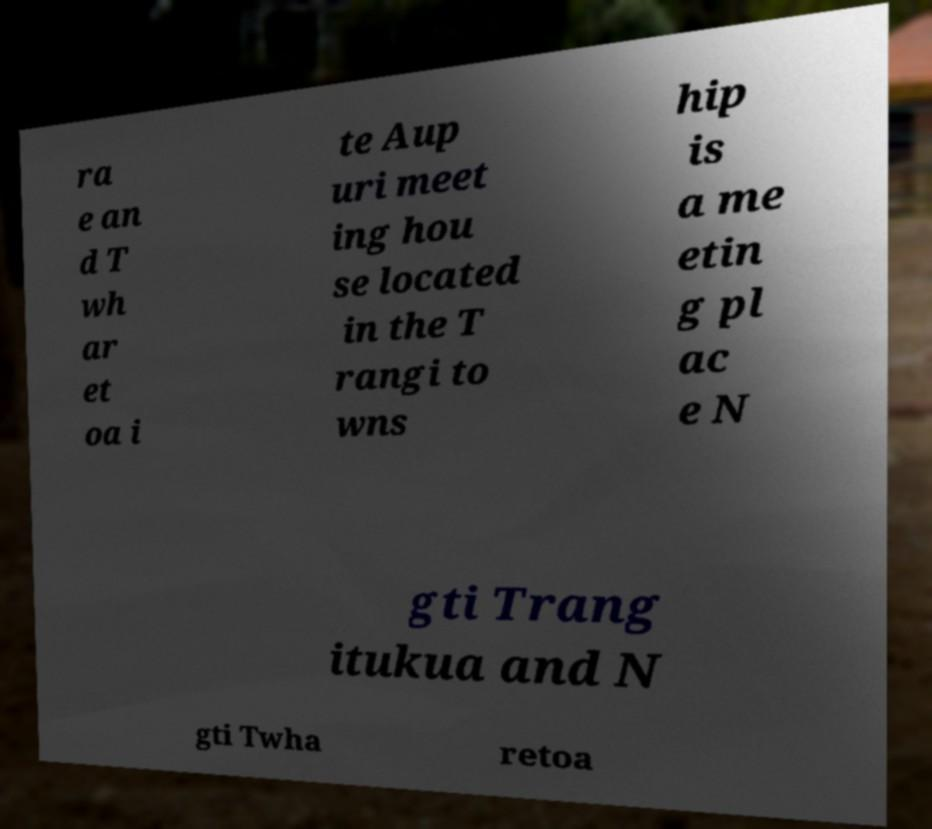Can you read and provide the text displayed in the image?This photo seems to have some interesting text. Can you extract and type it out for me? ra e an d T wh ar et oa i te Aup uri meet ing hou se located in the T rangi to wns hip is a me etin g pl ac e N gti Trang itukua and N gti Twha retoa 